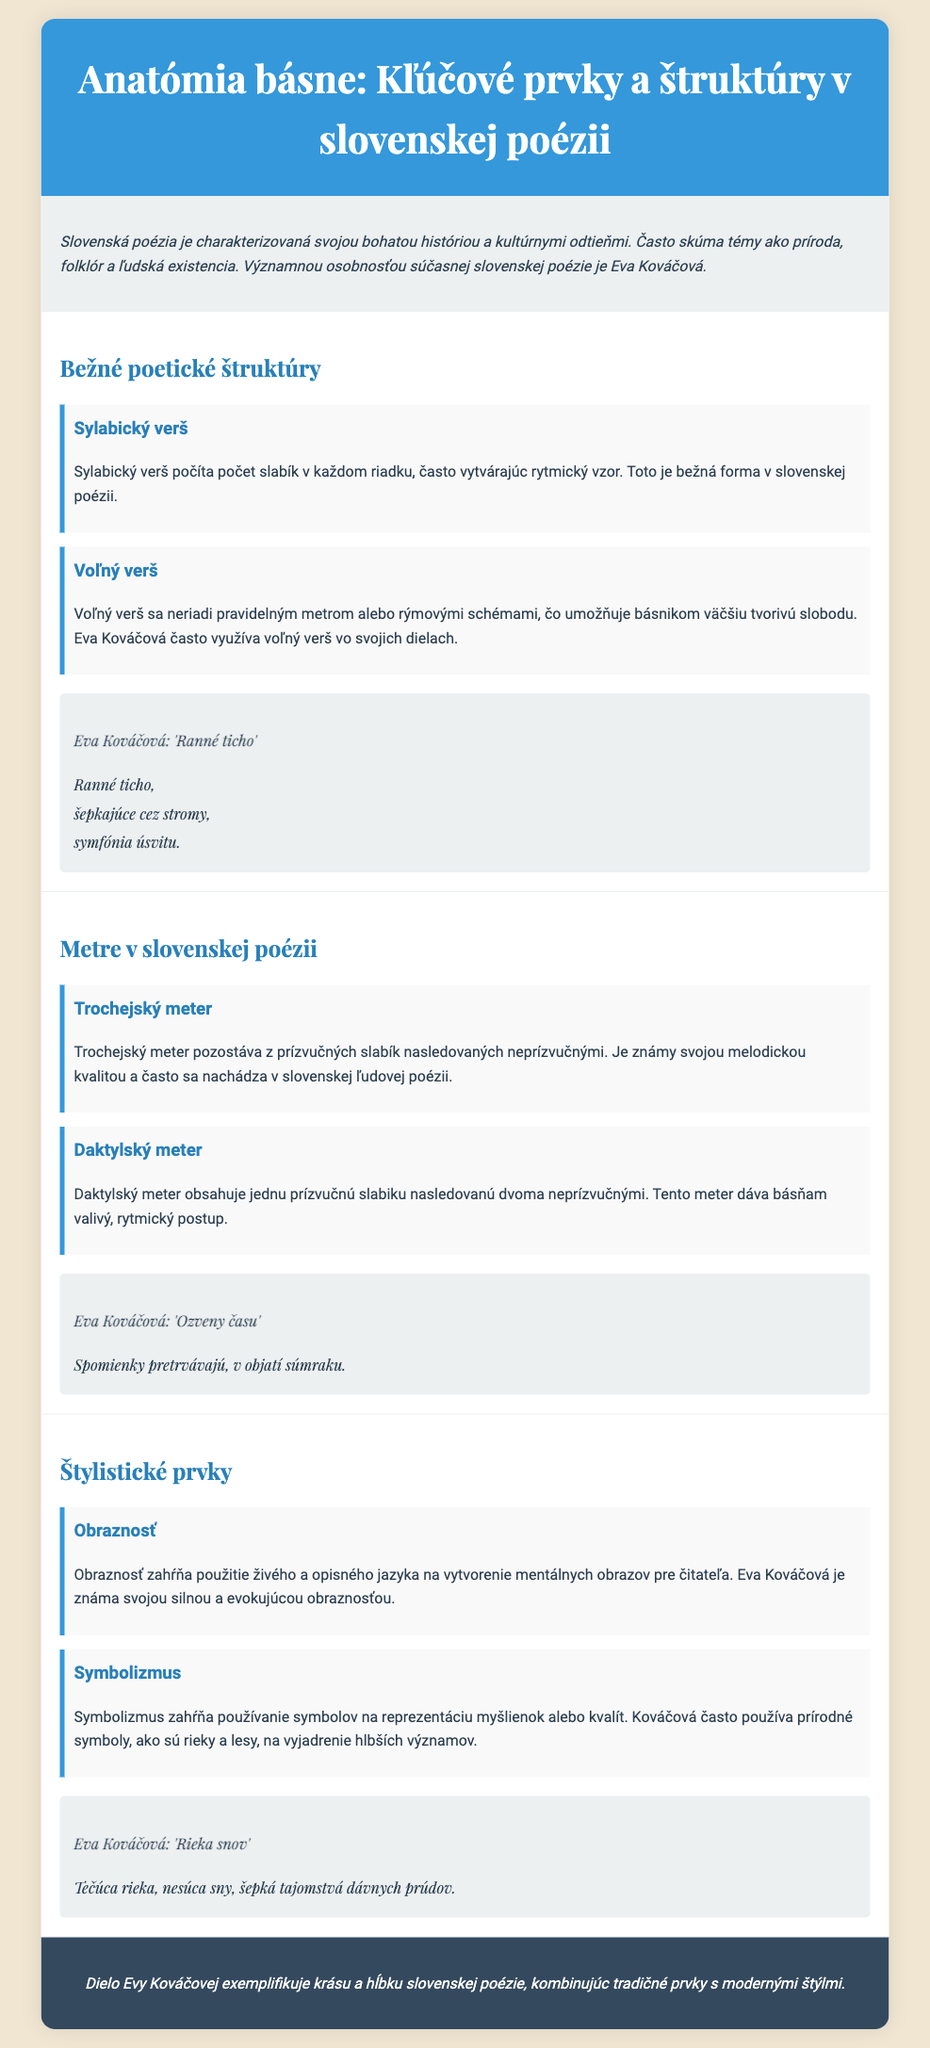what is the title of the infographic? The title is displayed prominently at the top of the document.
Answer: Anatómia básne: Kľúčové prvky a štruktúry v slovenskej poézii who is a significant personality in contemporary Slovak poetry mentioned in the document? The document highlights a prominent figure in Slovak poetry.
Answer: Eva Kováčová what poetic structure does the document describe as allowing greater creative freedom? The document explains different poetic structures, including one that offers flexibility.
Answer: Voľný verš which meter consists of one stressed syllable followed by two unstressed syllables? The document provides details on various meters in Slovak poetry.
Answer: Daktylský meter name one symbolic element commonly used by Eva Kováčová in her poetry. The document discusses symbolic elements in Kováčová's work.
Answer: Prírodné symboly which poem by Eva Kováčová is presented in the section about imagery? Each section includes an example poem from the author.
Answer: Rieka snov how does the document categorize the various stylistic elements? The sections of the document are dedicated to different artistic features in poetry.
Answer: Štylistické prvky what does the footer of the document summarize? The footer provides a concluding thought about the subject of the infographic.
Answer: Krásu a hĺbku slovenskej poézie 